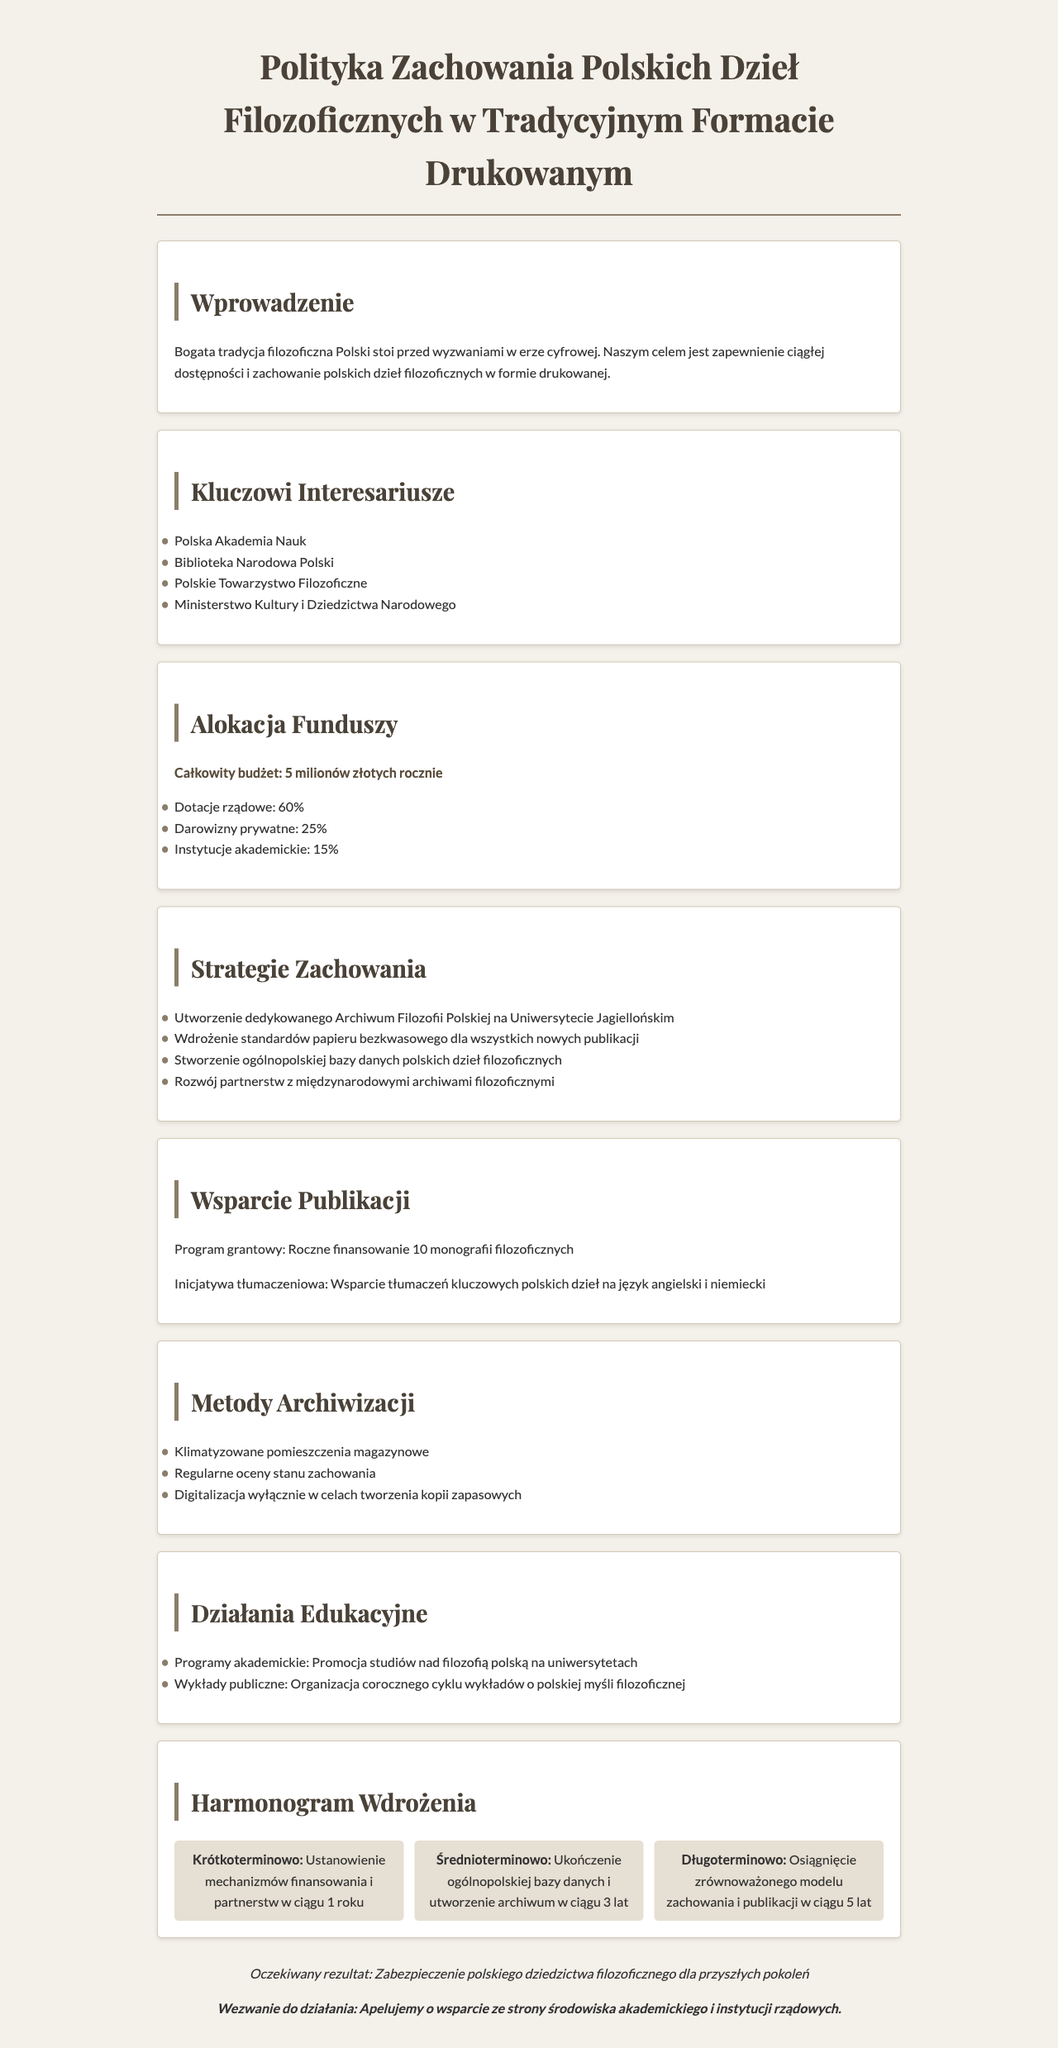What is the total budget for the policy? The total budget is explicitly stated in the document as 5 million złotych rocznie.
Answer: 5 milionów złotych rocznie Which institution is responsible for creating a dedicated archive? The document specifies that the Archiwum Filozofii Polskiej will be established at the Uniwersytet Jagielloński.
Answer: Uniwersytet Jagielloński What percentage of funding comes from government grants? The document notes that government grants account for 60% of the total funding allocation.
Answer: 60% What is a key strategy for preserving philosophical works? The document lists various strategies, one of which is the implementation of acid-free paper standards for all new publications.
Answer: Użytkowania papieru bezkwasowego What is the short-term action plan duration? The document describes the short-term action plan to establish funding mechanisms within 1 year.
Answer: 1 roku How many monographs will the grant program fund annually? The annual funding program will support 10 monographs as stated in the document.
Answer: 10 monografii What type of facilities will be used for storage? The document mentions that climate-controlled storage rooms will be implemented for preservation.
Answer: Klimatyzowane pomieszczenia magazynowe What is the primary call to action in the conclusion? The conclusion includes a strong appeal for support from the academic community and government institutions.
Answer: Apelujemy o wsparcie 